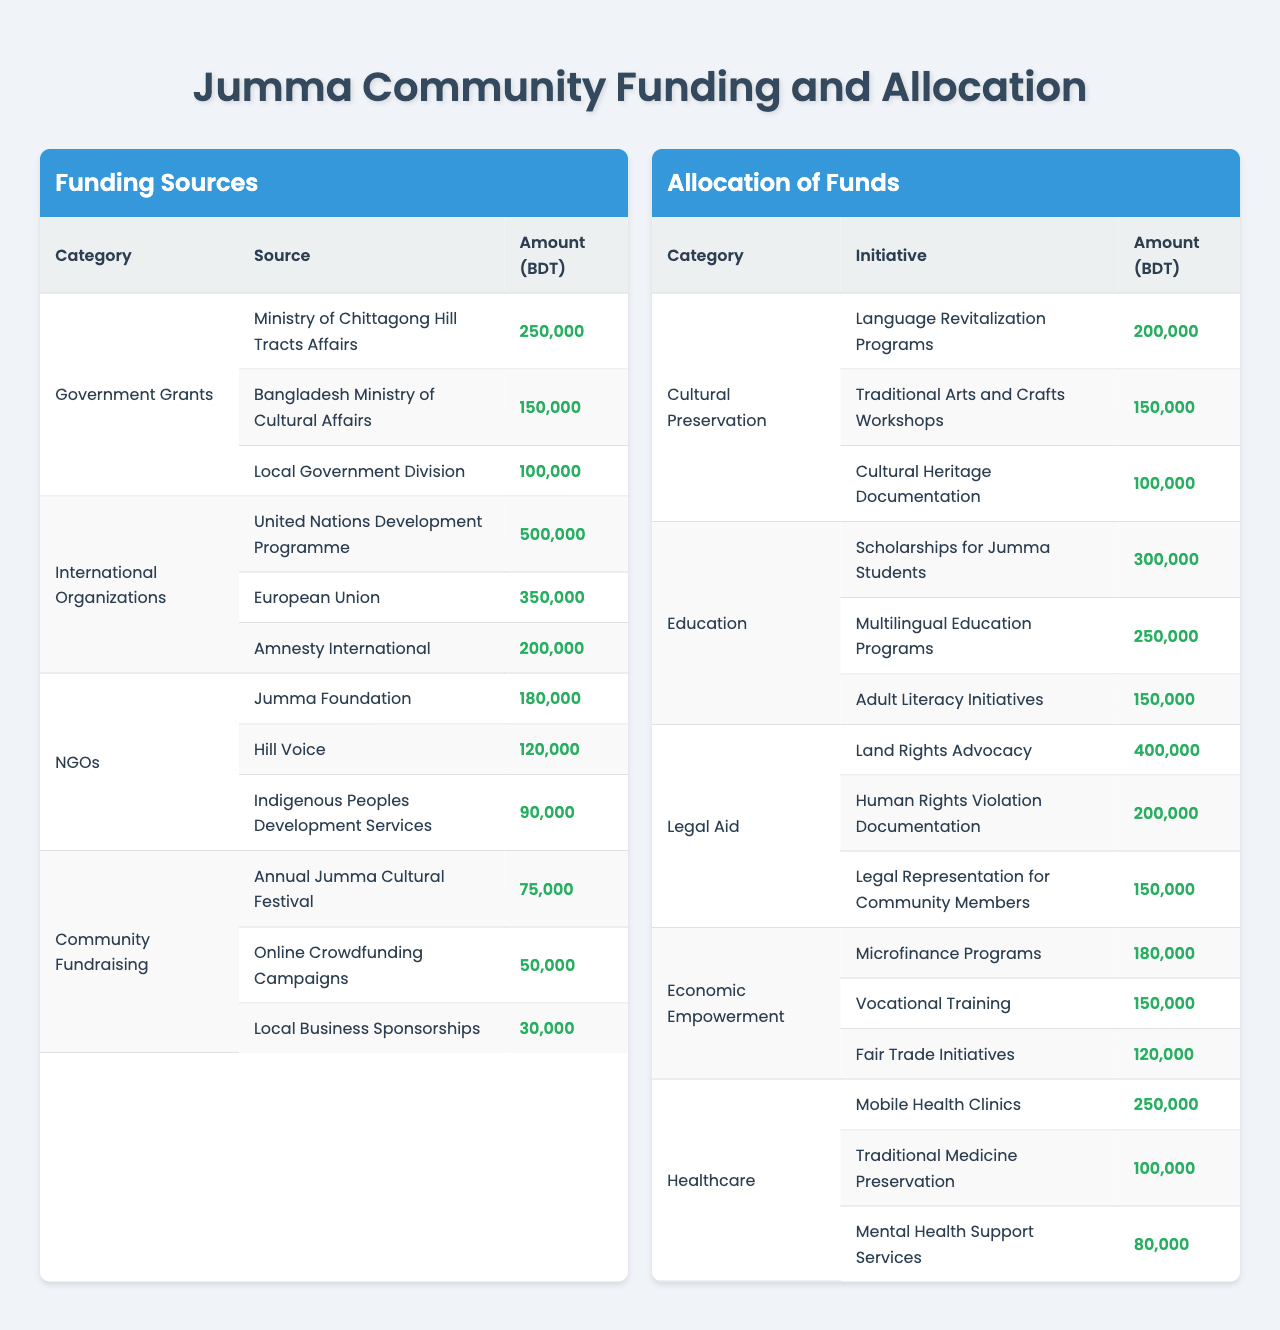What is the total amount allocated for Cultural Preservation? The allocation for Cultural Preservation includes Language Revitalization Programs (200,000), Traditional Arts and Crafts Workshops (150,000), and Cultural Heritage Documentation (100,000). Adding these amounts gives us 200,000 + 150,000 + 100,000 = 450,000.
Answer: 450,000 Which funding source provides the highest amount? Reviewing the funding sources, the United Nations Development Programme grants 500,000, which is the highest compared to other sources listed.
Answer: United Nations Development Programme What percentage of the total funding comes from International Organizations? The total funding from International Organizations is (500,000 + 350,000 + 200,000 = 1,050,000). The total funding from all sources is 2,645,000. Thus, the percentage is (1,050,000 / 2,645,000) * 100 = approximately 39.7%.
Answer: 39.7% Is there funding allocated for both Economic Empowerment and Legal Aid? Yes, there is funding allocated for both categories. Economic Empowerment has several initiatives, while Legal Aid also has its designated funding.
Answer: Yes What is the total amount allocated for Education initiatives? The allocations for Education initiatives are: Scholarships for Jumma Students (300,000), Multilingual Education Programs (250,000), and Adult Literacy Initiatives (150,000). Summing these gives us 300,000 + 250,000 + 150,000 = 700,000.
Answer: 700,000 Which category has the highest single allocation? The Legal Aid category has Land Rights Advocacy with an allocation of 400,000, which is higher than any single allocation in the other categories.
Answer: Legal Aid (Land Rights Advocacy) What is the total funding from NGOs? The total funding from NGOs is (180,000 + 120,000 + 90,000) = 390,000.
Answer: 390,000 If you consider all funding sources, which initiative receives the least amount of funding? The initiative which receives the least funding is Local Business Sponsorships in the Community Fundraising category, with an allocation of 30,000.
Answer: Local Business Sponsorships What is the total amount of funding available for Healthcare programs? The total funding for Healthcare includes Mobile Health Clinics (250,000), Traditional Medicine Preservation (100,000), and Mental Health Support Services (80,000). The total amount is 250,000 + 100,000 + 80,000 = 430,000.
Answer: 430,000 Can you list all the funding sources that provide more than 100,000 BDT? The sources providing more than 100,000 BDT are: United Nations Development Programme (500,000), European Union (350,000), Amnesty International (200,000), Ministry of Chittagong Hill Tracts Affairs (250,000), and Bangladesh Ministry of Cultural Affairs (150,000).
Answer: 5 sources: UNDP, EU, Amnesty, Ministry of Chittagong Hill Tracts Affairs, Bangladesh Ministry of Cultural Affairs 